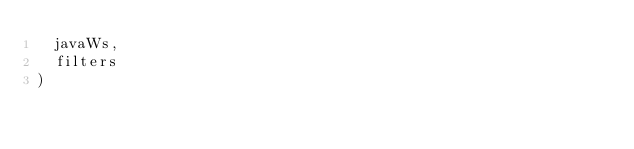Convert code to text. <code><loc_0><loc_0><loc_500><loc_500><_Scala_>  javaWs,
  filters
)

</code> 